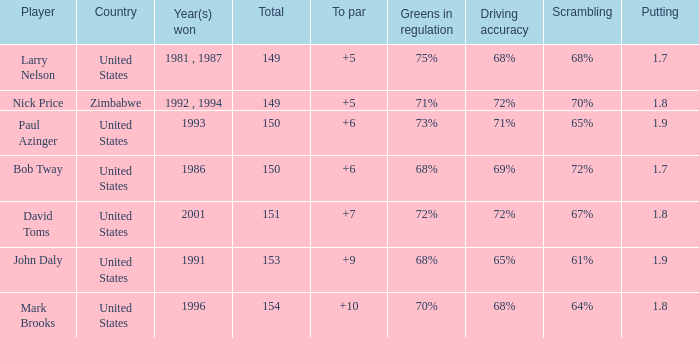Which player won in 1993? Paul Azinger. 